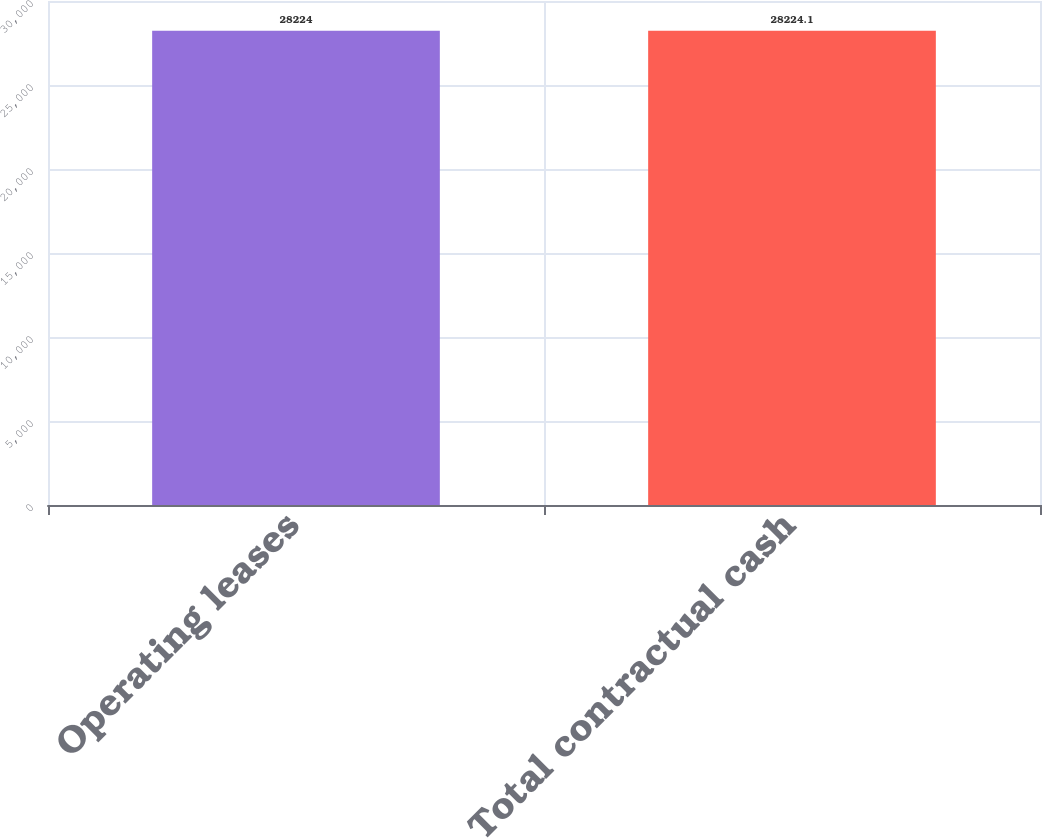<chart> <loc_0><loc_0><loc_500><loc_500><bar_chart><fcel>Operating leases<fcel>Total contractual cash<nl><fcel>28224<fcel>28224.1<nl></chart> 